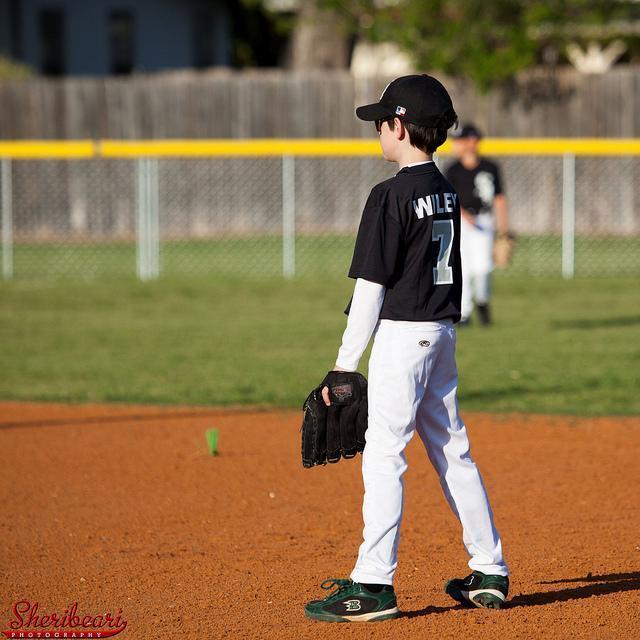How many different teams are represented in this picture?
Give a very brief answer. 1. How many people are there?
Give a very brief answer. 2. How many horses with a white stomach are there?
Give a very brief answer. 0. 